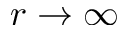Convert formula to latex. <formula><loc_0><loc_0><loc_500><loc_500>r \to \infty</formula> 